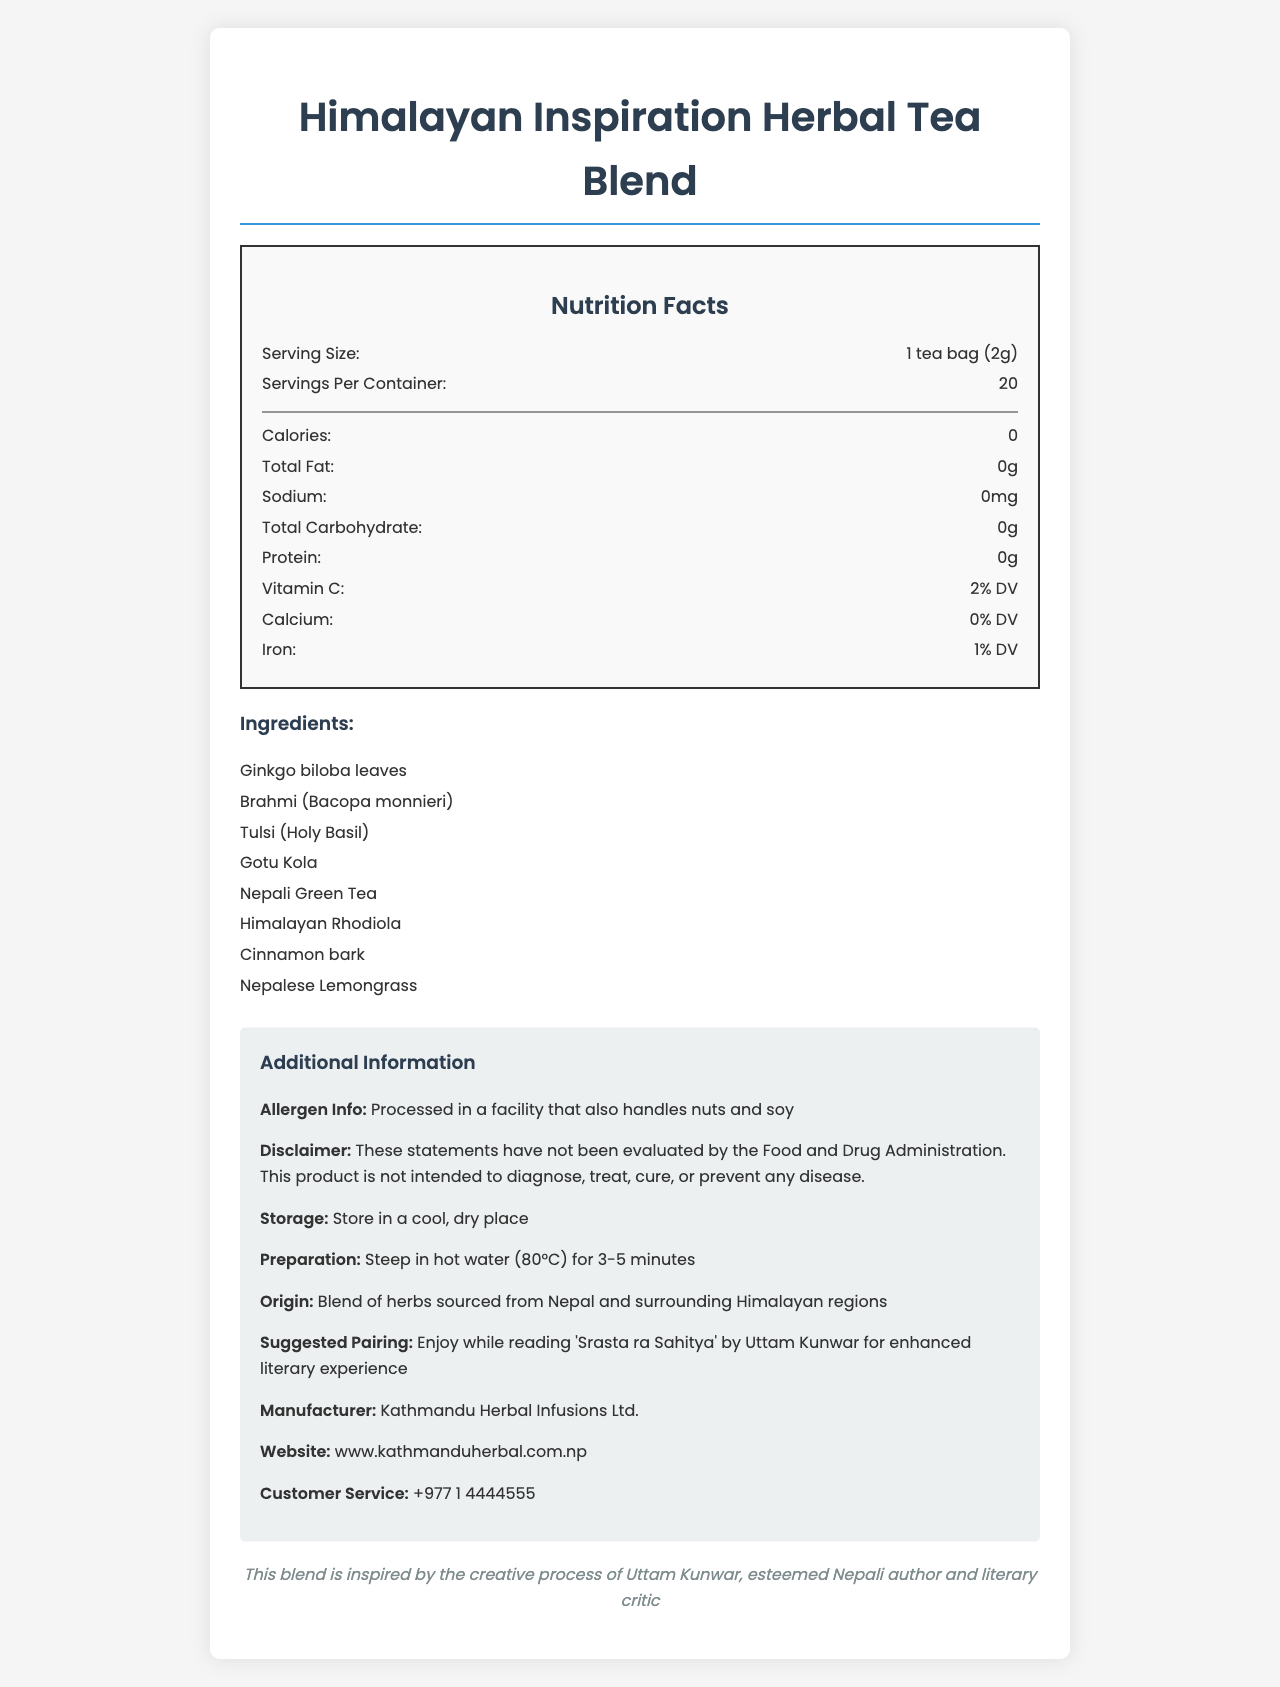what is the serving size of the Himalayan Inspiration Herbal Tea Blend? The serving size is listed at the top of the Nutrition Facts section as "1 tea bag (2g)."
Answer: 1 tea bag (2g) how many calories are in one serving of this herbal tea blend? The Nutrition Facts section explicitly states that there are 0 calories.
Answer: 0 which vitamin is present in the Himalayan Inspiration Herbal Tea Blend? Vitamin C is listed in the Nutrition Facts section with 2% DV.
Answer: Vitamin C how should you store the tea? The storage instructions are given under the Additional Information section, which states to store the tea in a cool, dry place.
Answer: Store in a cool, dry place which author's creative process inspired this tea blend? The literary inspiration mentioned at the bottom states that this tea blend is inspired by the creative process of Uttam Kunwar.
Answer: Uttam Kunwar what is the suggested literary pairing for this tea? The Suggested Pairing section in the Additional Information suggests enjoying the tea while reading 'Srasta ra Sahitya' by Uttam Kunwar.
Answer: 'Srasta ra Sahitya' by Uttam Kunwar how many servings are there per container? The Nutrition Facts section notes that there are 20 servings per container.
Answer: 20 who is the manufacturer of this product? The manufacturer is listed under the Additional Information section.
Answer: Kathmandu Herbal Infusions Ltd. which ingredient is not listed in the tea blend? A. Ginkgo biloba B. Jasmine flowers C. Brahmi D. Gotu Kola Jasmine flowers is not an ingredient listed in the Ingredients section.
Answer: B how many grams of protein does one serving of this tea contain? The Nutrition Facts section states that there is 0g of protein per serving.
Answer: 0g does the document mention any allergens? Yes or No The Allergen Info section mentions that the product is processed in a facility that also handles nuts and soy.
Answer: Yes how long should you steep the tea? The preparation instructions state to steep the tea for 3-5 minutes.
Answer: 3-5 minutes where are the herbs in the tea blend sourced from? A. India B. China C. Nepal and surrounding Himalayan regions D. Japan The Origin section states that the herbs are sourced from Nepal and surrounding Himalayan regions.
Answer: C summarize the document The summary encapsulates all the highlighted sections of the document including nutritional facts, inspiration, preparation, storage, ingredients, allergen information, and manufacturer details.
Answer: The document provides detailed nutritional information, ingredients, preparation and storage instructions, and additional information for the Himalayan Inspiration Herbal Tea Blend. It highlights that the tea contains 0 calories per serving, has no fat, sodium, carbohydrates, or protein, and includes Vitamin C, Calcium, and Iron in small amounts. The tea blend is inspired by the creative process of Uttam Kunwar and is suggested to be enjoyed while reading 'Srasta ra Sahitya' by the same author. The tea is produced by Kathmandu Herbal Infusions Ltd., and contains herbs sourced from Nepal and surrounding Himalayan regions. Allergen information notes possible contamination with nuts and soy. The preparation and storage guidelines are also provided along with manufacturer contact details. how much iron is present in the tea blend? The Nutrition Facts section lists Iron at 1% DV.
Answer: 1% DV what is the contact number for customer service? The contact number for customer service is listed in the Additional Information section.
Answer: +977 1 4444555 cannot determine the caffeine content in the tea blend from the document The document does not provide any information about caffeine content.
Answer: Cannot be determined 